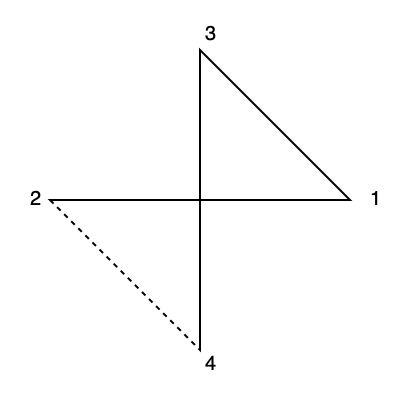The diagram shows the initial steps of folding a square piece of paper to create the Venus symbol, an iconic feminist symbol. If you were to fold the paper along the dotted line, which numbered corner would align with corner 3? To solve this problem, we need to mentally fold the paper along the dotted line and visualize the result. Let's break it down step-by-step:

1. The dotted line runs from the center of the square to the middle of the left side.

2. If we fold along this line, the bottom-left quarter of the square will be folded over the top-left quarter.

3. This means that corner 2 will move upwards and to the right, aligning with the top edge of the square.

4. As corner 2 moves, it will come to rest exactly where corner 3 is currently located.

5. Therefore, when the paper is folded along the dotted line, corner 2 will align with corner 3.

This mental folding exercise is crucial in understanding spatial relationships, which is often used in creating origami designs, including those representing feminist symbols.
Answer: 2 